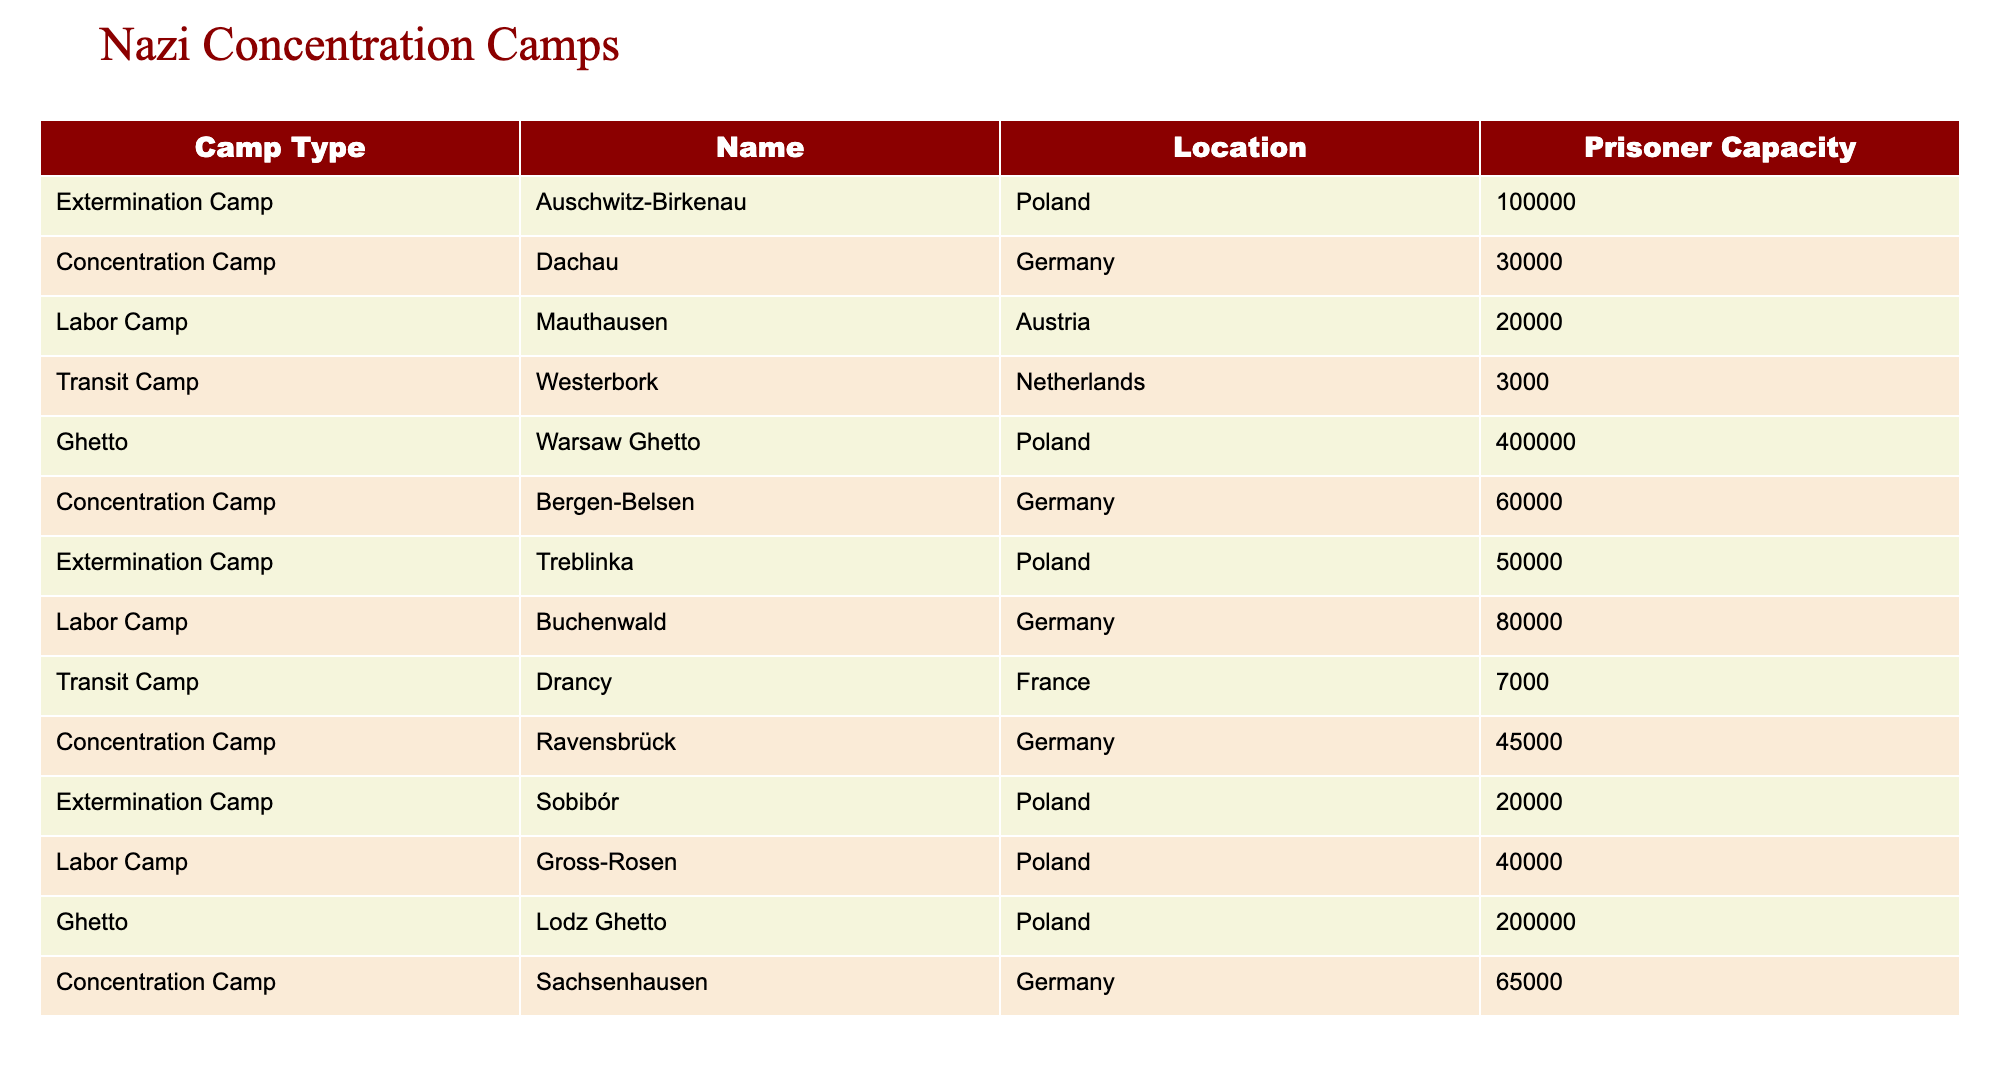What is the prisoner capacity of Auschwitz-Birkenau? Auschwitz-Birkenau has a listed prisoner capacity of 100,000 in the table.
Answer: 100,000 How many types of camps are listed in the table? The table lists four types of camps: Extermination Camp, Concentration Camp, Labor Camp, Transit Camp, and Ghetto. Counting them gives us a total of five different types.
Answer: 5 Which camp has the highest prisoner capacity? By comparing all the prisoner capacities in the table, Auschwitz-Birkenau has the highest capacity at 100,000.
Answer: Auschwitz-Birkenau What is the average prisoner capacity of the Labor Camps listed in the table? The Labor Camps listed are Mauthausen (20,000), Buchenwald (80,000), and Gross-Rosen (40,000). Adding these capacities gives 20,000 + 80,000 + 40,000 = 140,000, and dividing by the three camps gives an average of 140,000 / 3 = 46,667.
Answer: 46,667 Is the capacity of the Warsaw Ghetto greater than that of the combined capacities of all Labor Camps? The Warsaw Ghetto has a capacity of 400,000 and the Labor Camps total 140,000 (20,000 + 80,000 + 40,000 = 140,000). Since 400,000 is greater than 140,000, the answer is yes.
Answer: Yes Which type of camp has the lowest prisoner capacity? The table shows that the Transit Camp Westerbork has the lowest capacity at 3,000 compared to all other camps.
Answer: Transit Camp What is the total prisoner capacity of Concentration Camps listed in the table? The Concentration Camps listed are Dachau (30,000), Bergen-Belsen (60,000), Ravensbrück (45,000), and Sachsenhausen (65,000). Adding these gives a total of 30,000 + 60,000 + 45,000 + 65,000 = 200,000.
Answer: 200,000 Are there more Ghetto camps than Extermination camps in the table? The table lists two categories: Ghetto (2 camps) and Extermination Camps (3 camps). Since 2 is less than 3, the answer is no.
Answer: No What is the difference in capacity between the largest Ghetto and the largest Concentration Camp? The largest Ghetto, Warsaw Ghetto, has a capacity of 400,000, and the largest Concentration Camp, Sachsenhausen, has a capacity of 65,000. The difference is 400,000 - 65,000 = 335,000.
Answer: 335,000 